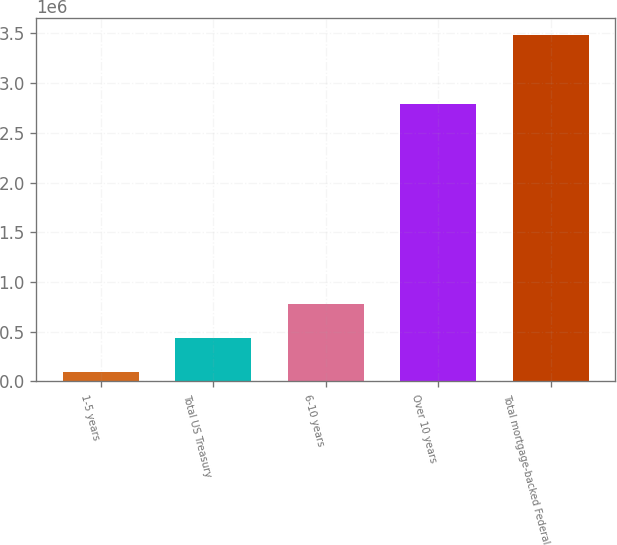Convert chart to OTSL. <chart><loc_0><loc_0><loc_500><loc_500><bar_chart><fcel>1-5 years<fcel>Total US Treasury<fcel>6-10 years<fcel>Over 10 years<fcel>Total mortgage-backed Federal<nl><fcel>99154<fcel>437249<fcel>775345<fcel>2.79169e+06<fcel>3.48011e+06<nl></chart> 